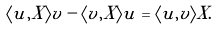<formula> <loc_0><loc_0><loc_500><loc_500>\langle u , X \rangle v - \langle v , X \rangle u = \langle u , v \rangle X .</formula> 